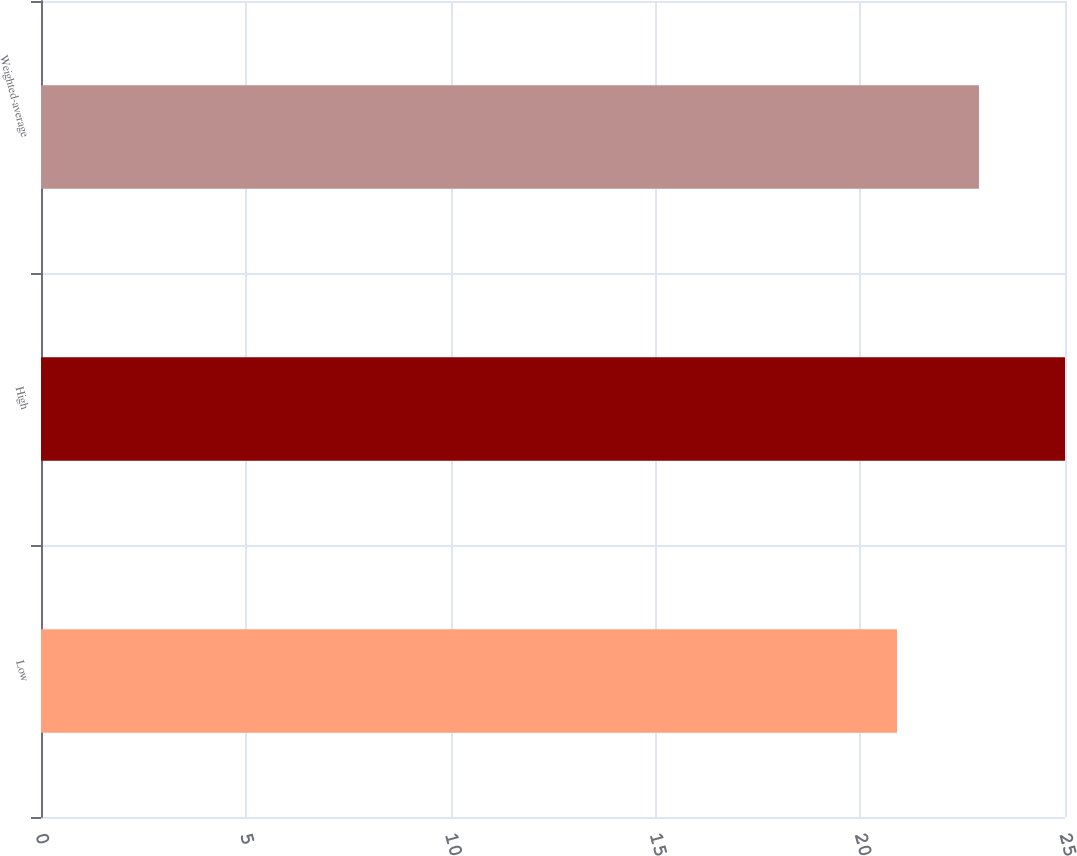<chart> <loc_0><loc_0><loc_500><loc_500><bar_chart><fcel>Low<fcel>High<fcel>Weighted-average<nl><fcel>20.9<fcel>25<fcel>22.9<nl></chart> 